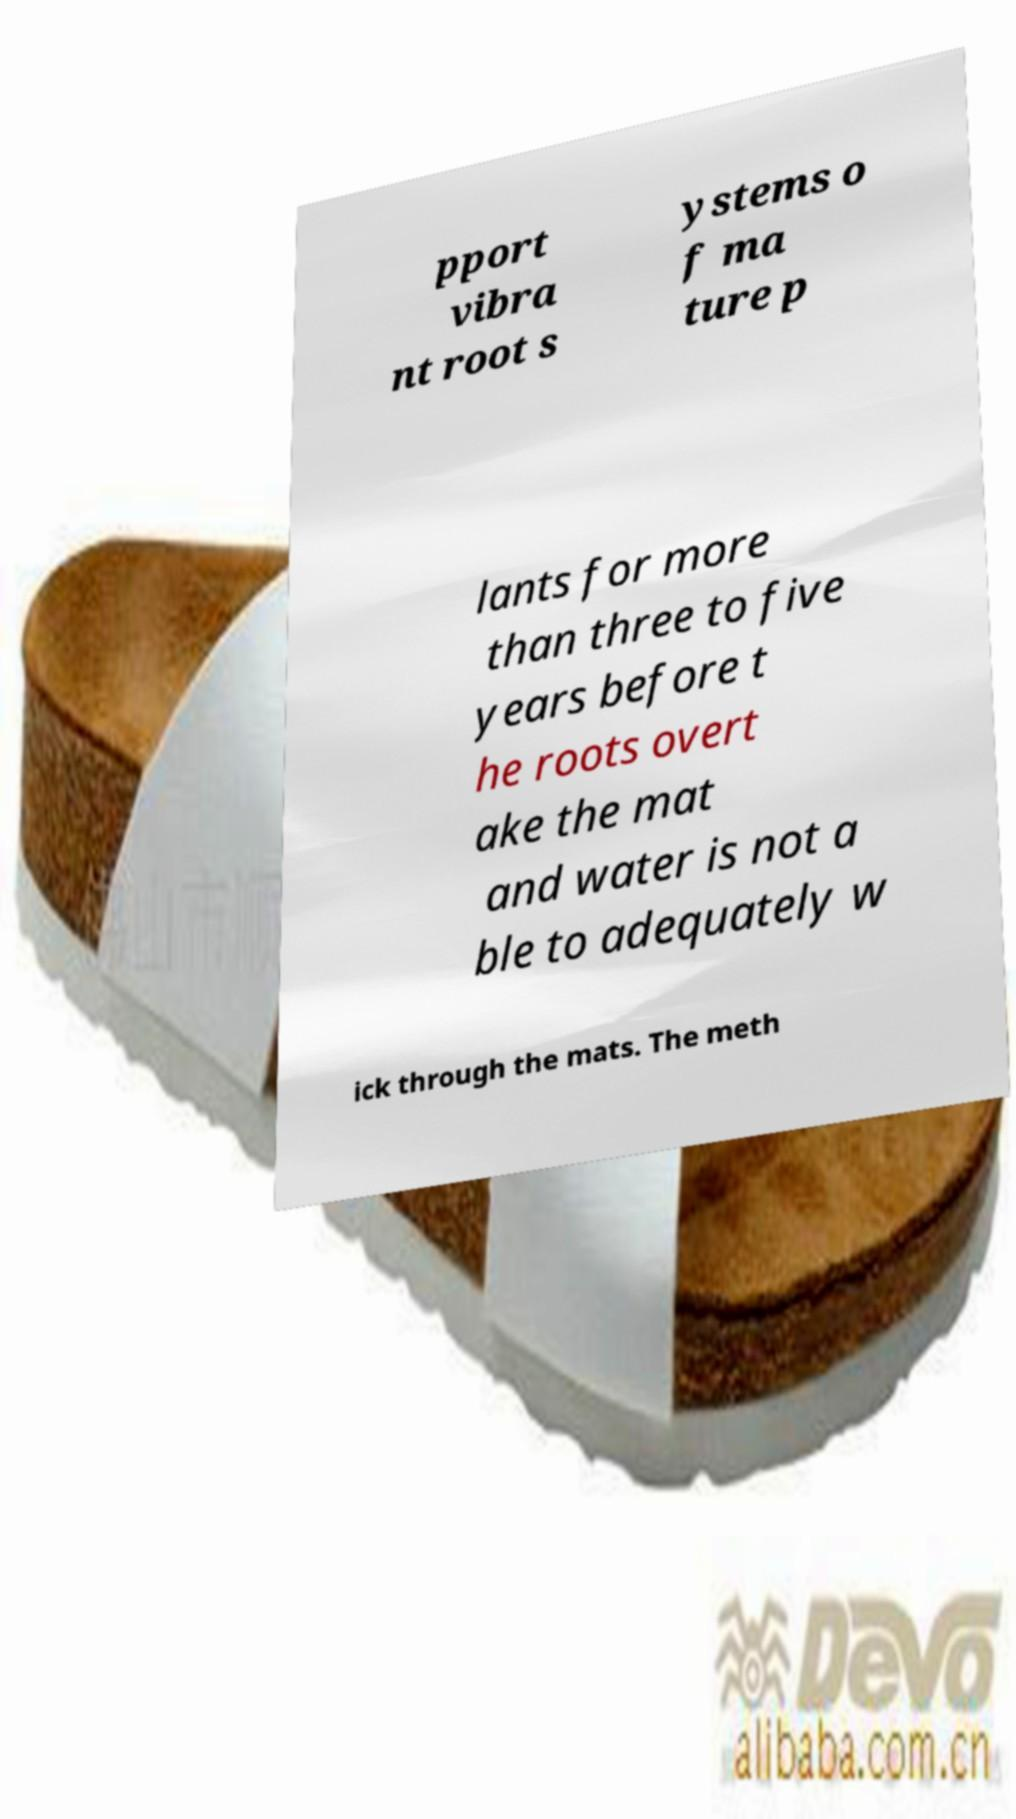What messages or text are displayed in this image? I need them in a readable, typed format. pport vibra nt root s ystems o f ma ture p lants for more than three to five years before t he roots overt ake the mat and water is not a ble to adequately w ick through the mats. The meth 